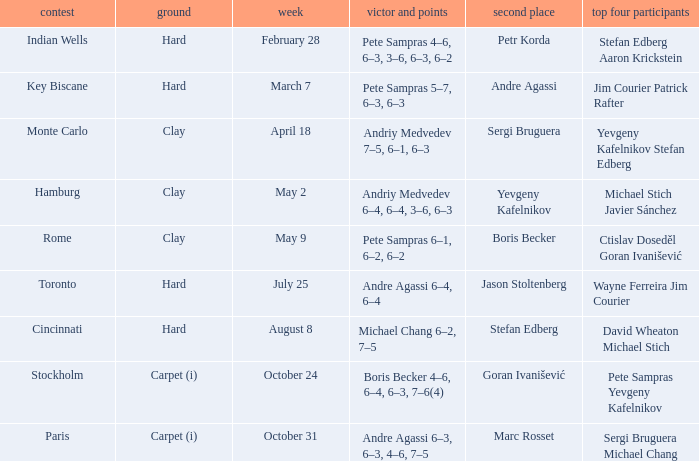Who was the semifinalist for the key biscane tournament? Jim Courier Patrick Rafter. 